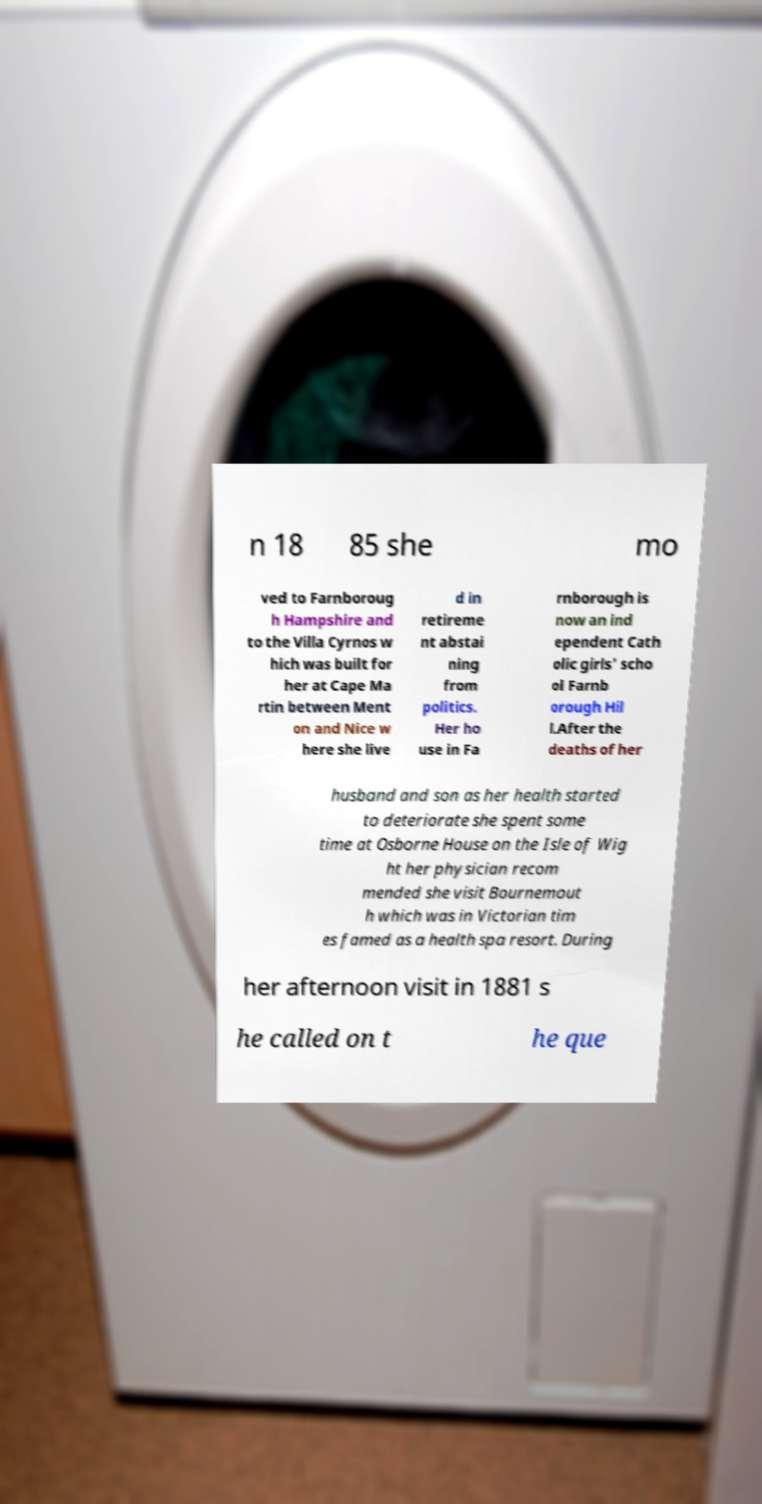Can you accurately transcribe the text from the provided image for me? n 18 85 she mo ved to Farnboroug h Hampshire and to the Villa Cyrnos w hich was built for her at Cape Ma rtin between Ment on and Nice w here she live d in retireme nt abstai ning from politics. Her ho use in Fa rnborough is now an ind ependent Cath olic girls' scho ol Farnb orough Hil l.After the deaths of her husband and son as her health started to deteriorate she spent some time at Osborne House on the Isle of Wig ht her physician recom mended she visit Bournemout h which was in Victorian tim es famed as a health spa resort. During her afternoon visit in 1881 s he called on t he que 